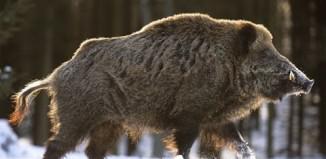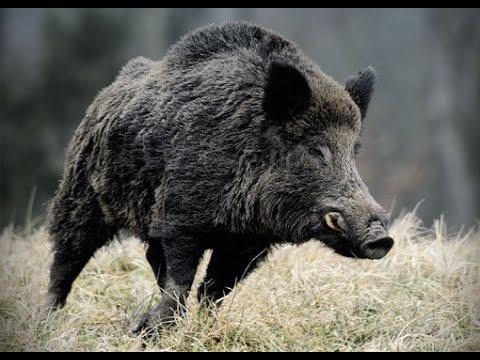The first image is the image on the left, the second image is the image on the right. Examine the images to the left and right. Is the description "In one image the ground is not covered in snow." accurate? Answer yes or no. Yes. 